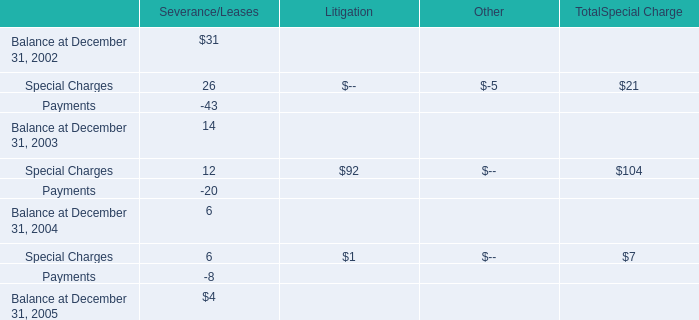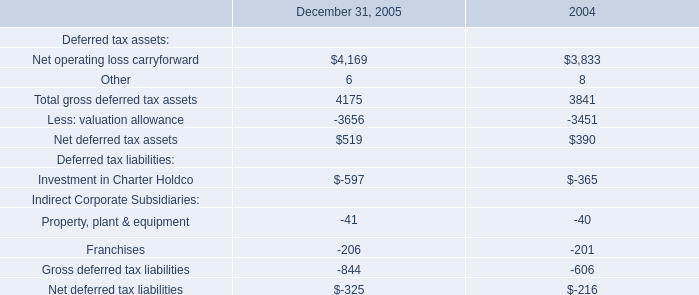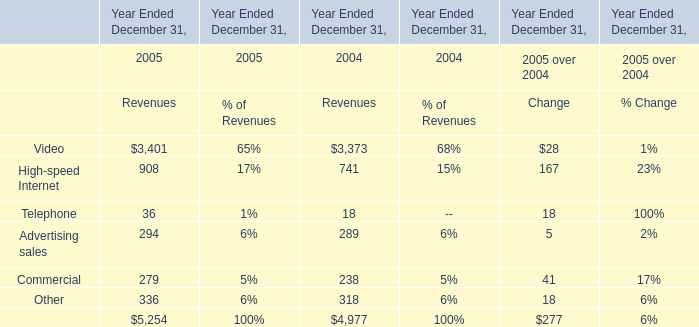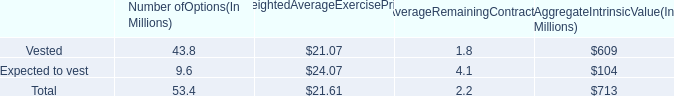What will High-speed Internet reach in 2006 if it continues to grow at its current rate? 
Computations: (908 * (1 + ((908 - 741) / 741)))
Answer: 1112.63698. 